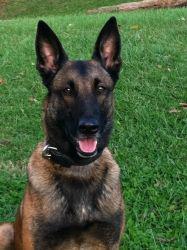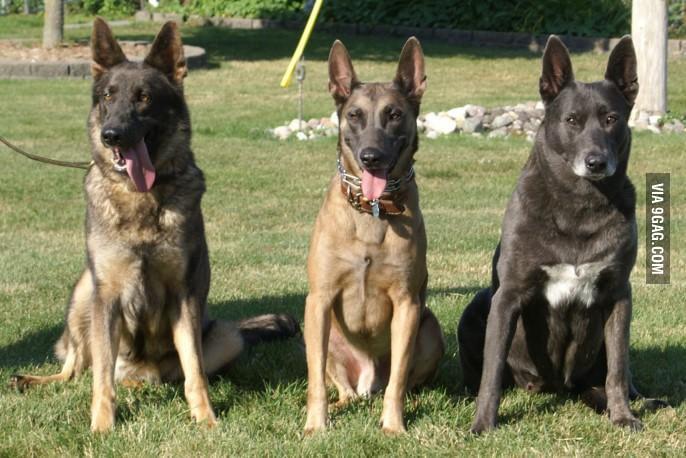The first image is the image on the left, the second image is the image on the right. Given the left and right images, does the statement "The right image contains exactly three dogs." hold true? Answer yes or no. Yes. The first image is the image on the left, the second image is the image on the right. For the images shown, is this caption "Three german shepherd dogs sit upright in a row on grass in one image." true? Answer yes or no. Yes. 